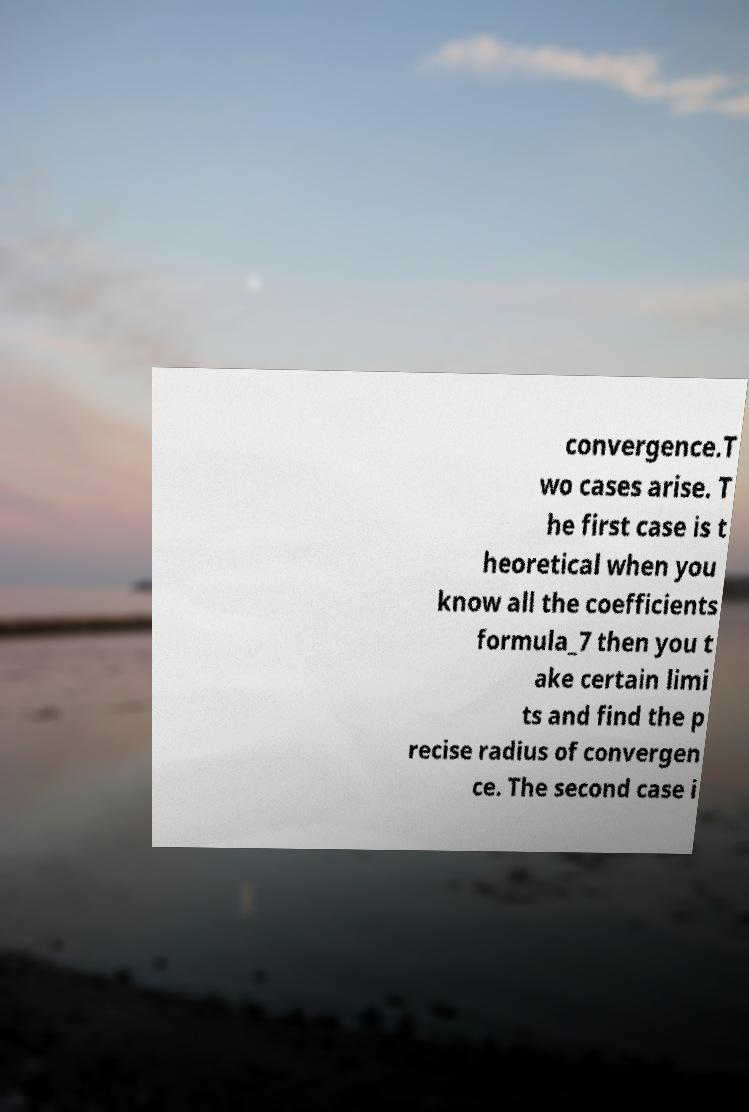For documentation purposes, I need the text within this image transcribed. Could you provide that? convergence.T wo cases arise. T he first case is t heoretical when you know all the coefficients formula_7 then you t ake certain limi ts and find the p recise radius of convergen ce. The second case i 